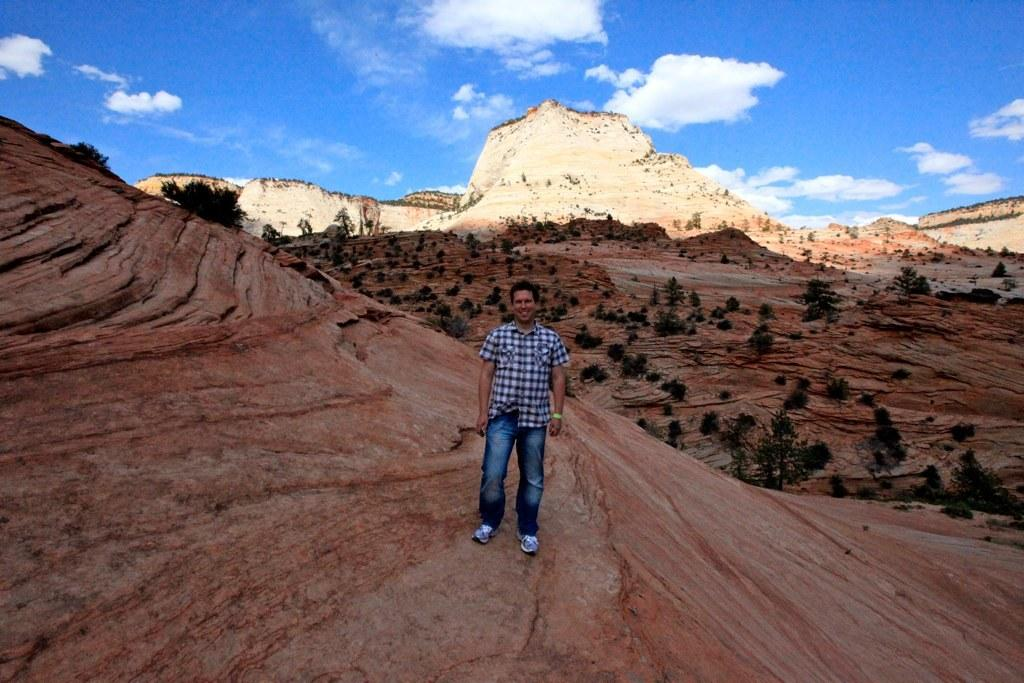What is the main subject in the foreground of the image? There is a man standing in the foreground of the image. What is the man standing on? The man is standing on a rock-like surface. What can be seen in the background of the image? There are trees, mountains, and the sky visible in the background of the image. What is the condition of the sky in the image? The sky is visible in the background of the image, and there are clouds present. Can you tell me how many people are requesting to swim at the airport in the image? There is no airport or swimming activity present in the image; it features a man standing on a rock-like surface with trees, mountains, and clouds in the background. 